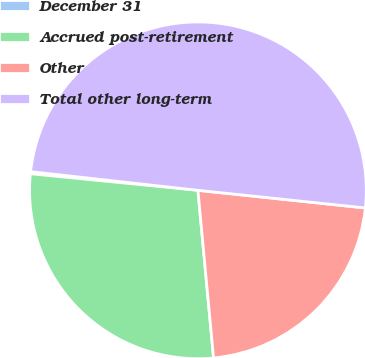Convert chart. <chart><loc_0><loc_0><loc_500><loc_500><pie_chart><fcel>December 31<fcel>Accrued post-retirement<fcel>Other<fcel>Total other long-term<nl><fcel>0.2%<fcel>28.05%<fcel>21.85%<fcel>49.9%<nl></chart> 